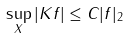<formula> <loc_0><loc_0><loc_500><loc_500>\sup _ { X } | K f | \leq C | f | _ { 2 }</formula> 